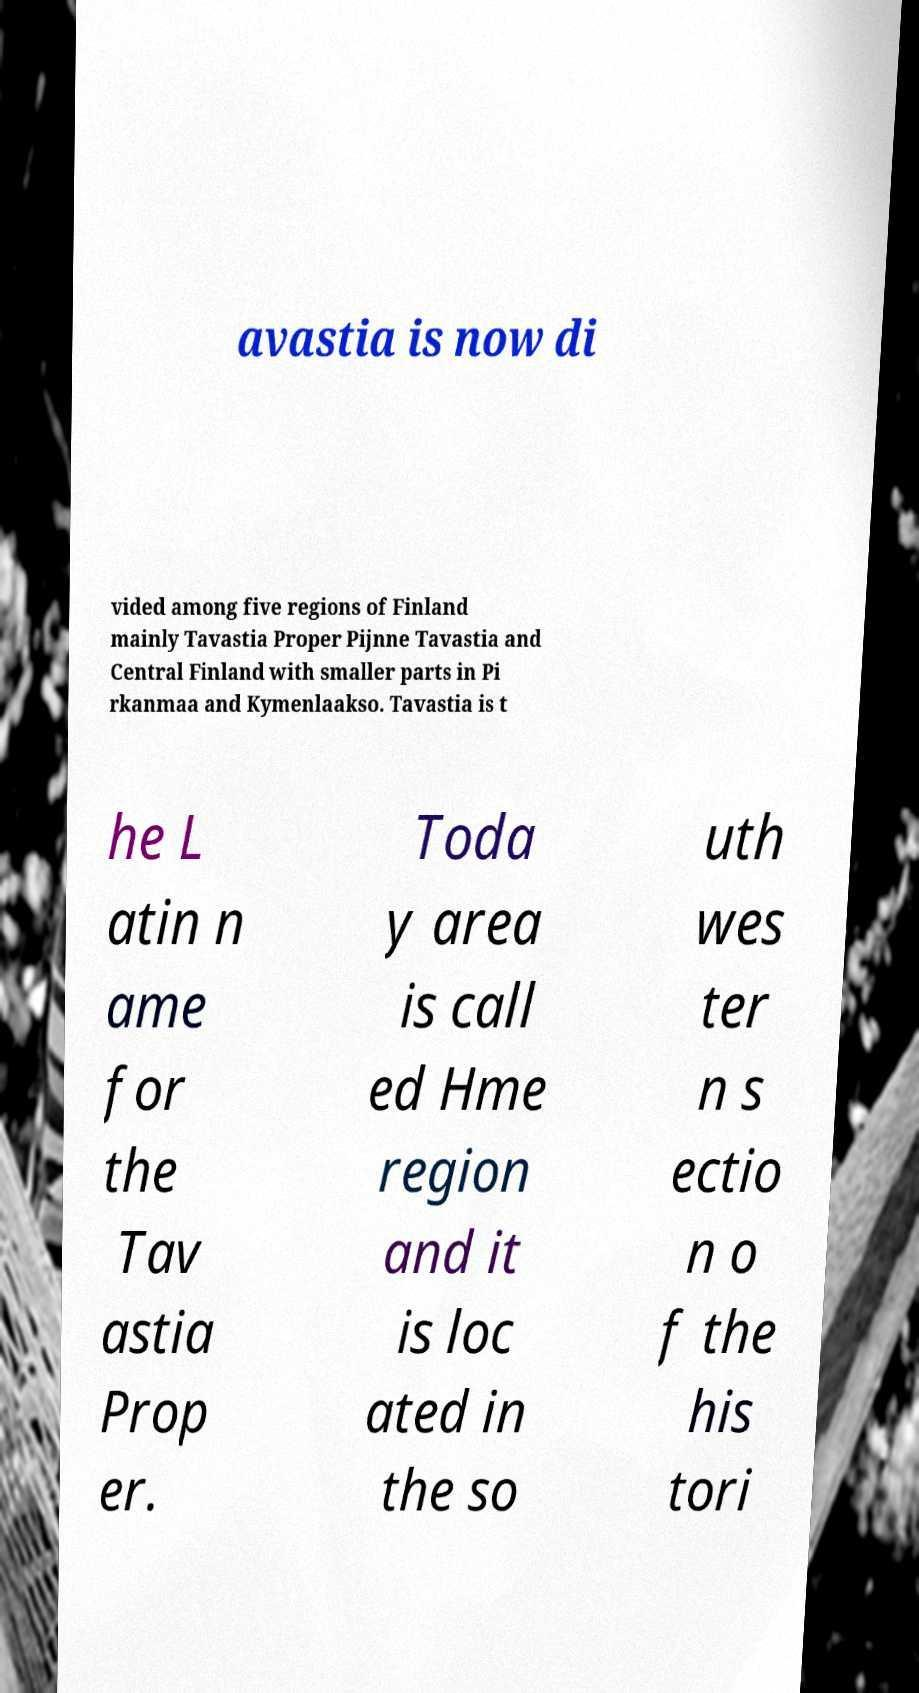Please read and relay the text visible in this image. What does it say? avastia is now di vided among five regions of Finland mainly Tavastia Proper Pijnne Tavastia and Central Finland with smaller parts in Pi rkanmaa and Kymenlaakso. Tavastia is t he L atin n ame for the Tav astia Prop er. Toda y area is call ed Hme region and it is loc ated in the so uth wes ter n s ectio n o f the his tori 